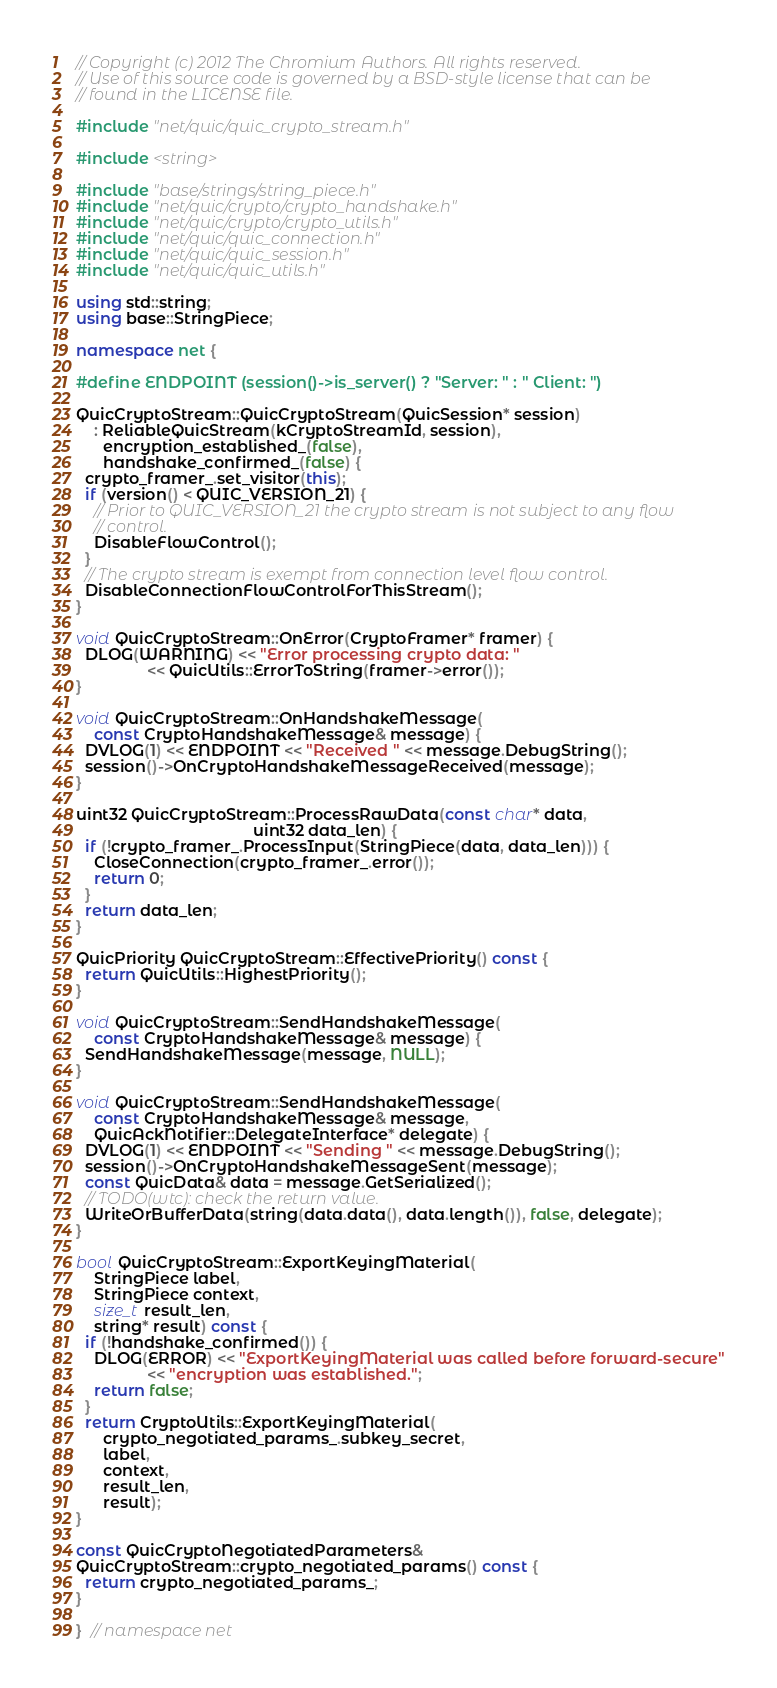Convert code to text. <code><loc_0><loc_0><loc_500><loc_500><_C++_>// Copyright (c) 2012 The Chromium Authors. All rights reserved.
// Use of this source code is governed by a BSD-style license that can be
// found in the LICENSE file.

#include "net/quic/quic_crypto_stream.h"

#include <string>

#include "base/strings/string_piece.h"
#include "net/quic/crypto/crypto_handshake.h"
#include "net/quic/crypto/crypto_utils.h"
#include "net/quic/quic_connection.h"
#include "net/quic/quic_session.h"
#include "net/quic/quic_utils.h"

using std::string;
using base::StringPiece;

namespace net {

#define ENDPOINT (session()->is_server() ? "Server: " : " Client: ")

QuicCryptoStream::QuicCryptoStream(QuicSession* session)
    : ReliableQuicStream(kCryptoStreamId, session),
      encryption_established_(false),
      handshake_confirmed_(false) {
  crypto_framer_.set_visitor(this);
  if (version() < QUIC_VERSION_21) {
    // Prior to QUIC_VERSION_21 the crypto stream is not subject to any flow
    // control.
    DisableFlowControl();
  }
  // The crypto stream is exempt from connection level flow control.
  DisableConnectionFlowControlForThisStream();
}

void QuicCryptoStream::OnError(CryptoFramer* framer) {
  DLOG(WARNING) << "Error processing crypto data: "
                << QuicUtils::ErrorToString(framer->error());
}

void QuicCryptoStream::OnHandshakeMessage(
    const CryptoHandshakeMessage& message) {
  DVLOG(1) << ENDPOINT << "Received " << message.DebugString();
  session()->OnCryptoHandshakeMessageReceived(message);
}

uint32 QuicCryptoStream::ProcessRawData(const char* data,
                                        uint32 data_len) {
  if (!crypto_framer_.ProcessInput(StringPiece(data, data_len))) {
    CloseConnection(crypto_framer_.error());
    return 0;
  }
  return data_len;
}

QuicPriority QuicCryptoStream::EffectivePriority() const {
  return QuicUtils::HighestPriority();
}

void QuicCryptoStream::SendHandshakeMessage(
    const CryptoHandshakeMessage& message) {
  SendHandshakeMessage(message, NULL);
}

void QuicCryptoStream::SendHandshakeMessage(
    const CryptoHandshakeMessage& message,
    QuicAckNotifier::DelegateInterface* delegate) {
  DVLOG(1) << ENDPOINT << "Sending " << message.DebugString();
  session()->OnCryptoHandshakeMessageSent(message);
  const QuicData& data = message.GetSerialized();
  // TODO(wtc): check the return value.
  WriteOrBufferData(string(data.data(), data.length()), false, delegate);
}

bool QuicCryptoStream::ExportKeyingMaterial(
    StringPiece label,
    StringPiece context,
    size_t result_len,
    string* result) const {
  if (!handshake_confirmed()) {
    DLOG(ERROR) << "ExportKeyingMaterial was called before forward-secure"
                << "encryption was established.";
    return false;
  }
  return CryptoUtils::ExportKeyingMaterial(
      crypto_negotiated_params_.subkey_secret,
      label,
      context,
      result_len,
      result);
}

const QuicCryptoNegotiatedParameters&
QuicCryptoStream::crypto_negotiated_params() const {
  return crypto_negotiated_params_;
}

}  // namespace net
</code> 